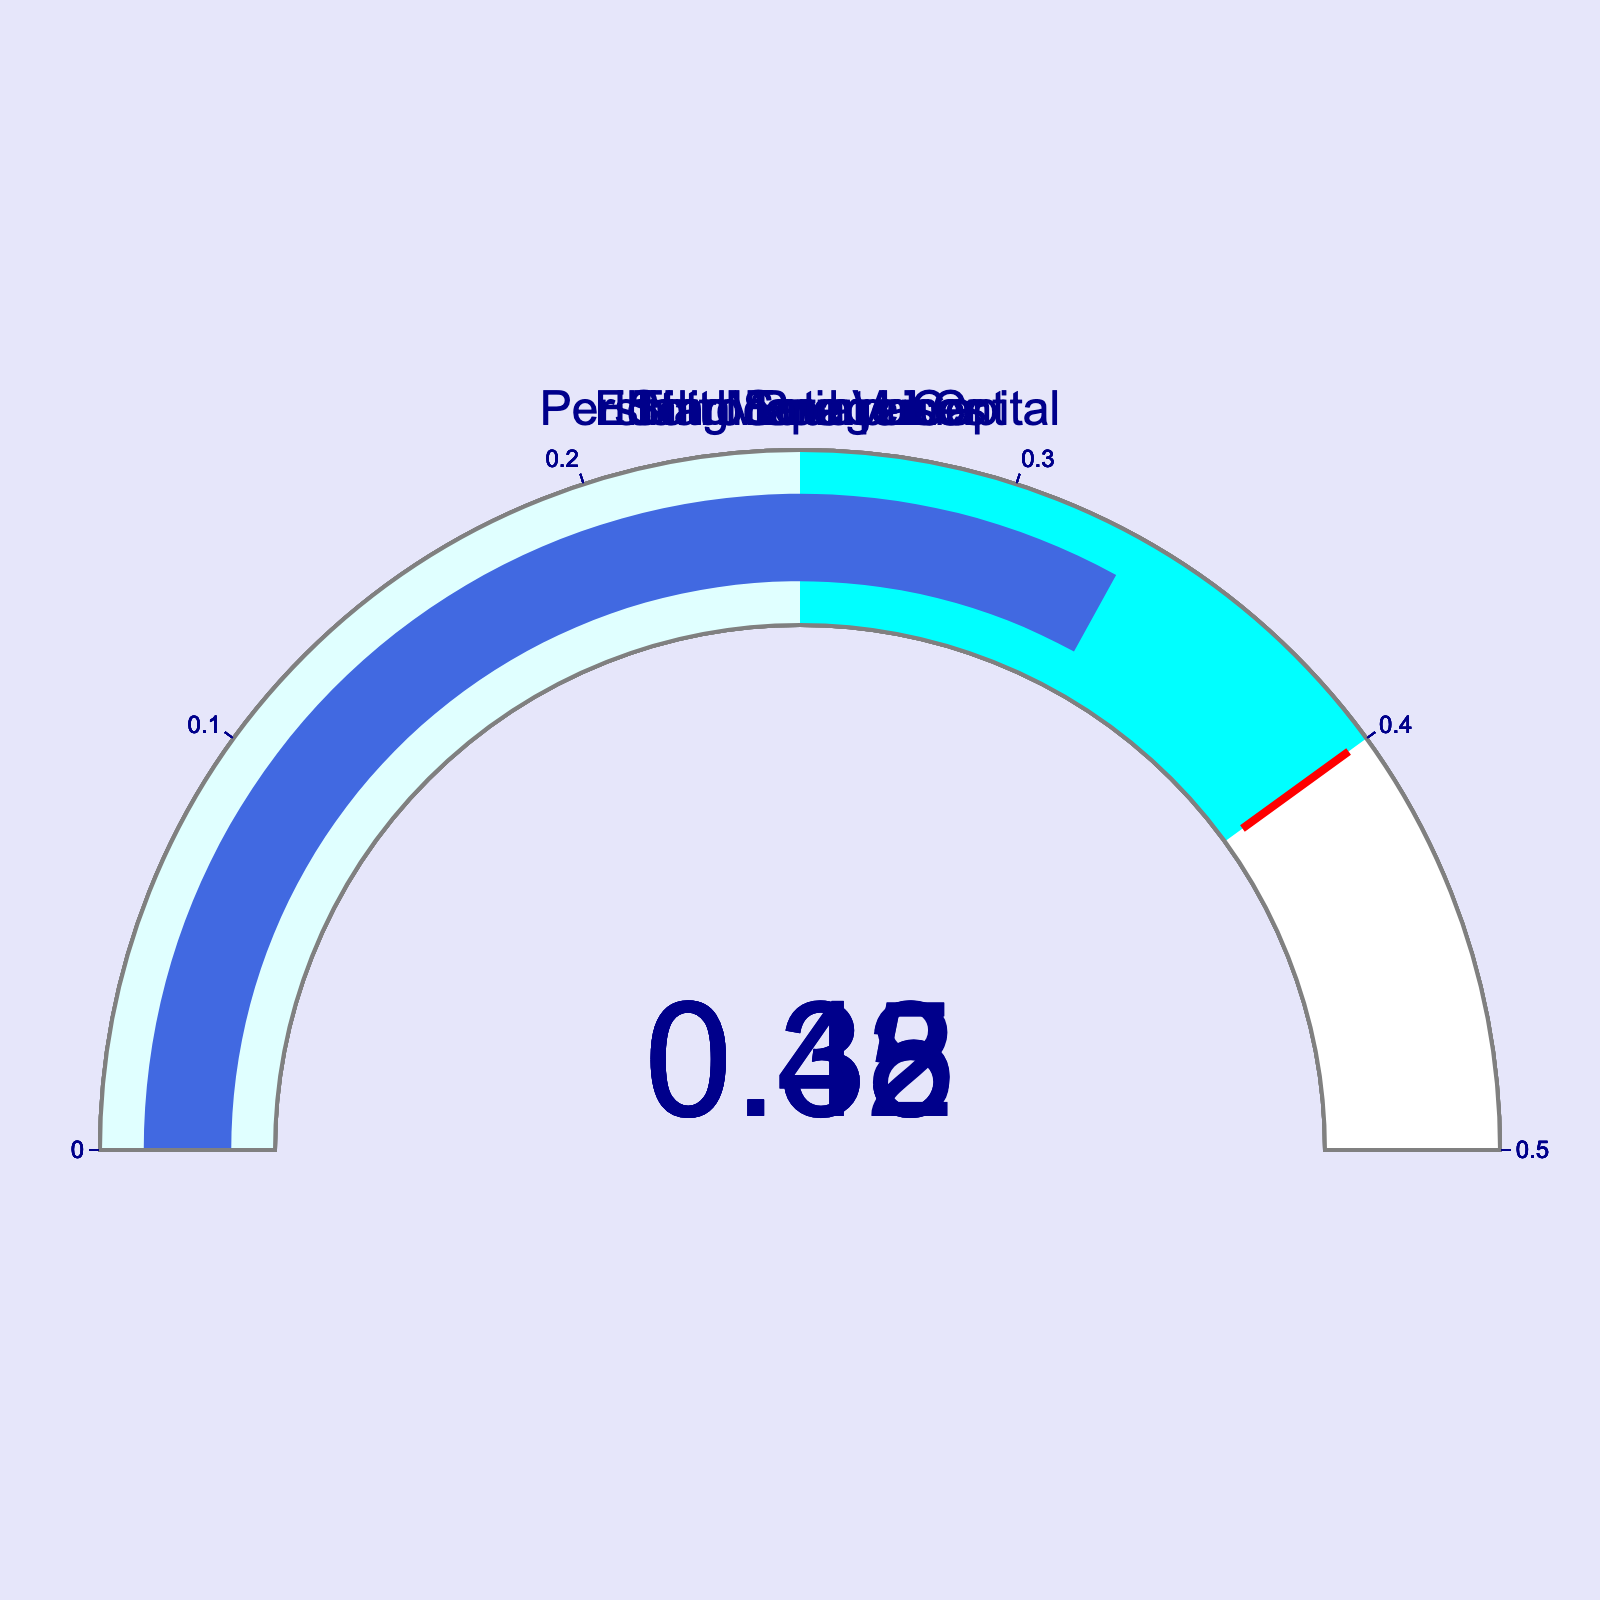What company has the highest ratio of successful activist investor proposals? To find the company with the highest ratio, we need to look at the gauge chart and identify the highest value displayed. Starboard Value shows the highest value at 0.45.
Answer: Starboard Value Which company has the lowest ratio of successful activist investor proposals? Identifying the lowest ratio involves looking at the gauges and finding the smallest value. Icahn Enterprises has the lowest ratio at 0.33.
Answer: Icahn Enterprises What is the range of the ratios displayed on the gauge charts? The range is the difference between the highest and lowest values. The highest value is 0.45 (Starboard Value) and the lowest is 0.33 (Icahn Enterprises), so the range is 0.45 - 0.33 = 0.12.
Answer: 0.12 Which companies have a ratio of successful proposals below the threshold of 0.4? The threshold is marked at 0.4 by the red line on the gauges. The companies with ratios below this value are Elliott Management (0.38), Third Point LLC (0.35), and Icahn Enterprises (0.33).
Answer: Elliott Management, Third Point LLC, Icahn Enterprises What's the average ratio of successful activist investor proposals among all companies? To compute the average, add all the ratios and divide by the number of companies. The values are 0.42, 0.38, 0.35, 0.45, and 0.33. The sum is 0.42 + 0.38 + 0.35 + 0.45 + 0.33 = 1.93. Dividing by 5 gives 1.93 / 5 = 0.386.
Answer: 0.386 How many companies have a ratio greater than or equal to 0.35? Any ratio greater than or equal to 0.35 qualifies. The companies with ratios 0.42 (Pershing Square Capital), 0.38 (Elliott Management), 0.35 (Third Point LLC), and 0.45 (Starboard Value) meet this criterion. Thus, there are 4 companies.
Answer: 4 Which company's ratio is closest to the midpoint of the gauges (0.25 to 0.4 range)? The midpoint of the range 0.25 to 0.4 is 0.325. Observing the values, the closest ratios to 0.325 are Third Point LLC (0.35) and Icahn Enterprises (0.33). Between these, 0.33 is the closest.
Answer: Icahn Enterprises What is the difference between the ratios of the top two companies with the highest ratios? The top two companies are Starboard Value (0.45) and Pershing Square Capital (0.42). The difference is 0.45 - 0.42 = 0.03.
Answer: 0.03 